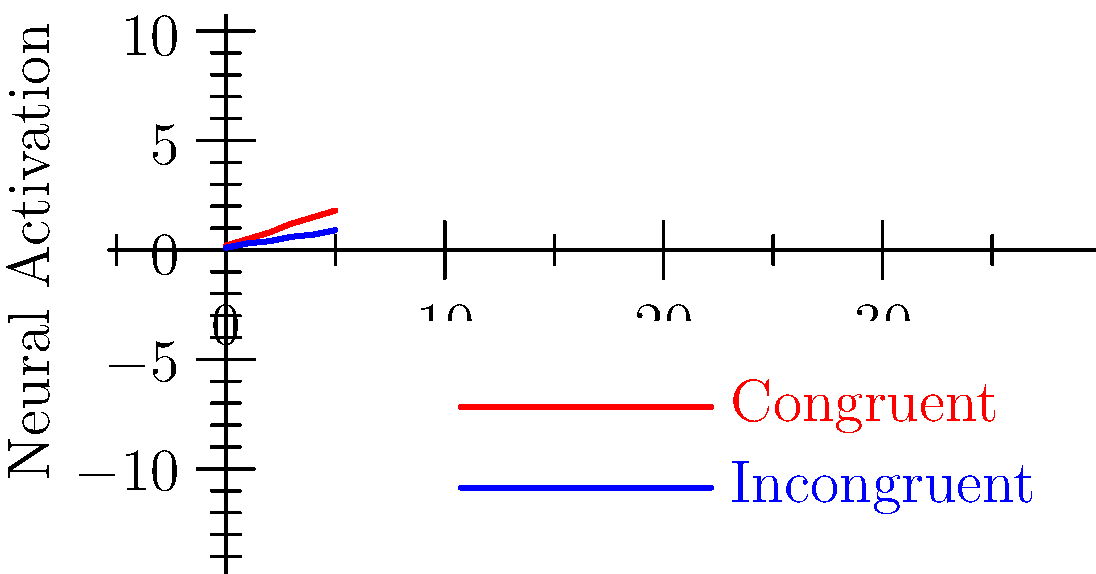Based on the fMRI activation patterns shown in the graph, which condition consistently demonstrates higher neural activation, and what might this suggest about the integration of audiovisual stimuli in the brain? To answer this question, let's analyze the graph step-by-step:

1. The graph shows two lines representing neural activation over time for two conditions: congruent (red) and incongruent (blue) audiovisual stimuli.

2. Comparing the two lines:
   - The red line (congruent) is consistently higher than the blue line (incongruent) at all time points.
   - The difference between the two lines appears to increase over time.

3. Higher neural activation in the congruent condition suggests:
   - More efficient processing of matching audiovisual information.
   - Enhanced integration of congruent audiovisual stimuli in the brain.

4. The increasing difference over time might indicate:
   - A cumulative effect of congruence on neural processing.
   - Possible recruitment of additional neural networks for congruent stimuli.

5. This pattern aligns with the principle of multisensory integration, where congruent information from different sensory modalities is combined more effectively in the brain.

6. The findings are consistent with research by Mark T. Wallace and colleagues on audiovisual integration in the superior temporal sulcus and other multisensory areas.

Therefore, the congruent condition consistently shows higher neural activation, suggesting more efficient and extensive processing of matching audiovisual information in the brain.
Answer: Congruent; enhanced multisensory integration 